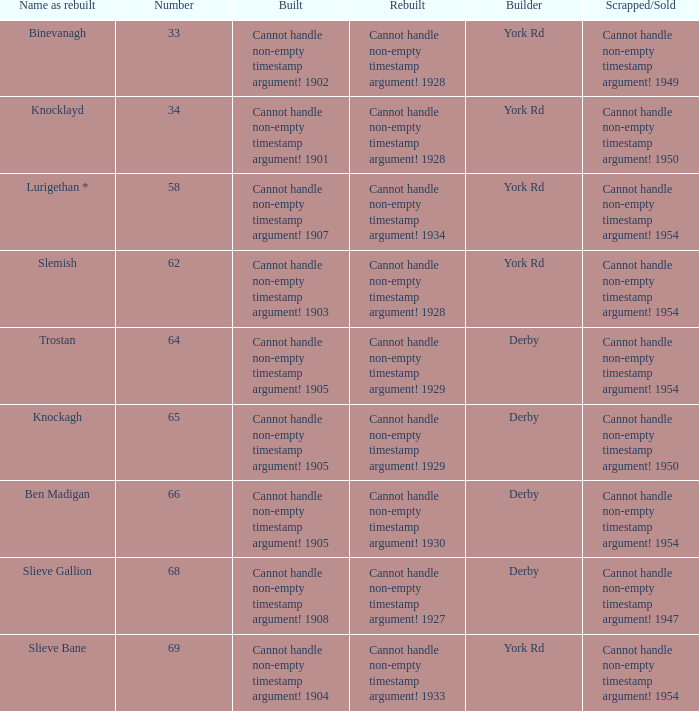Which Rebuilt has a Builder of derby, and a Name as rebuilt of ben madigan? Cannot handle non-empty timestamp argument! 1930. 